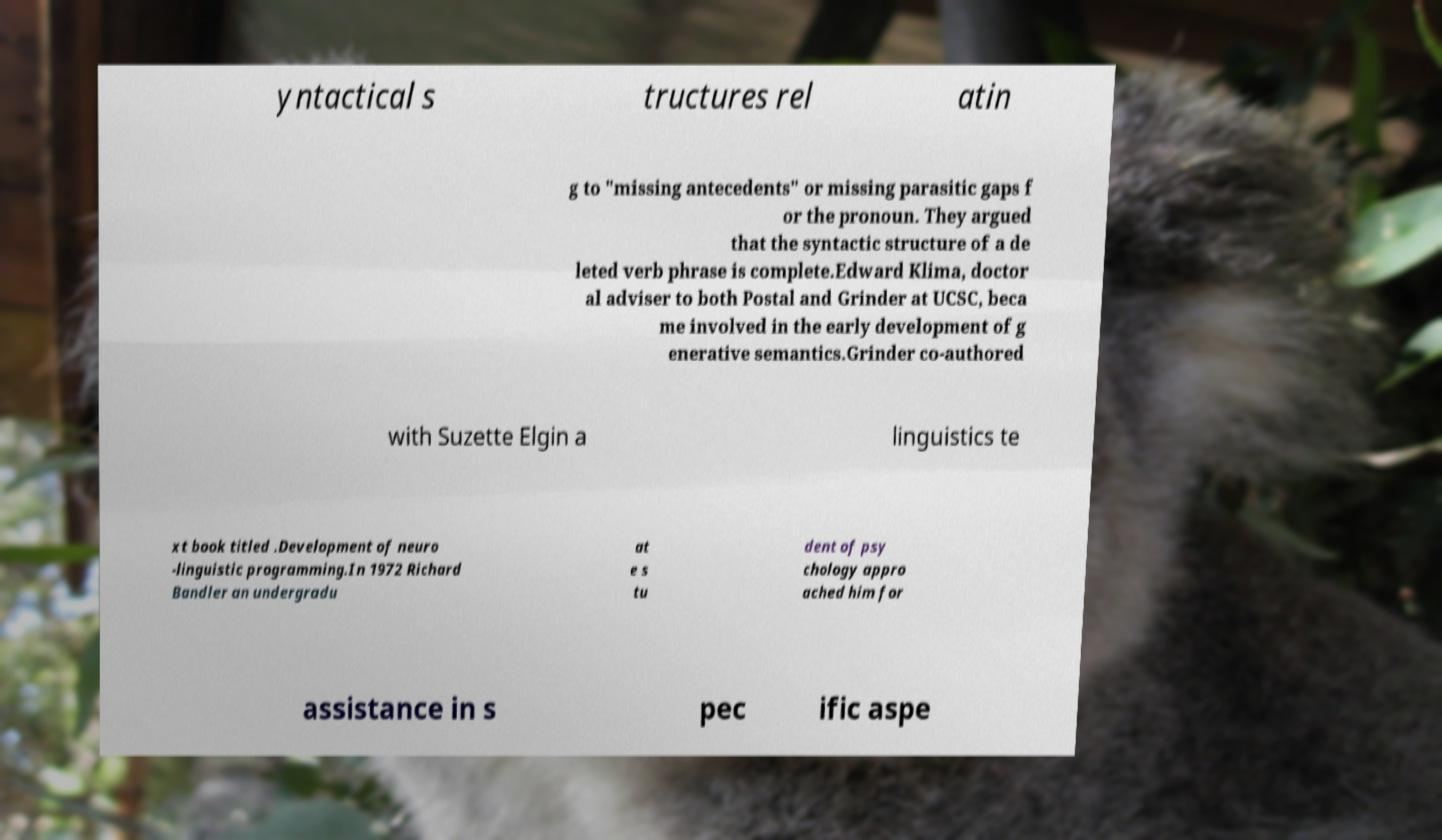Please identify and transcribe the text found in this image. yntactical s tructures rel atin g to "missing antecedents" or missing parasitic gaps f or the pronoun. They argued that the syntactic structure of a de leted verb phrase is complete.Edward Klima, doctor al adviser to both Postal and Grinder at UCSC, beca me involved in the early development of g enerative semantics.Grinder co-authored with Suzette Elgin a linguistics te xt book titled .Development of neuro -linguistic programming.In 1972 Richard Bandler an undergradu at e s tu dent of psy chology appro ached him for assistance in s pec ific aspe 